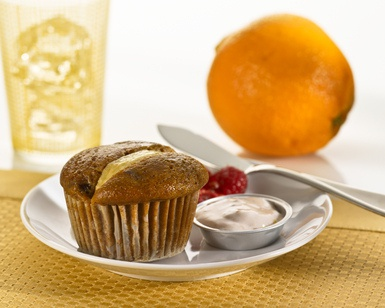Describe the objects in this image and their specific colors. I can see dining table in beige, tan, olive, and orange tones, orange in beige, orange, and red tones, cup in beige, khaki, and gold tones, cake in beige, olive, maroon, and tan tones, and knife in beige, tan, lightgray, ivory, and darkgray tones in this image. 